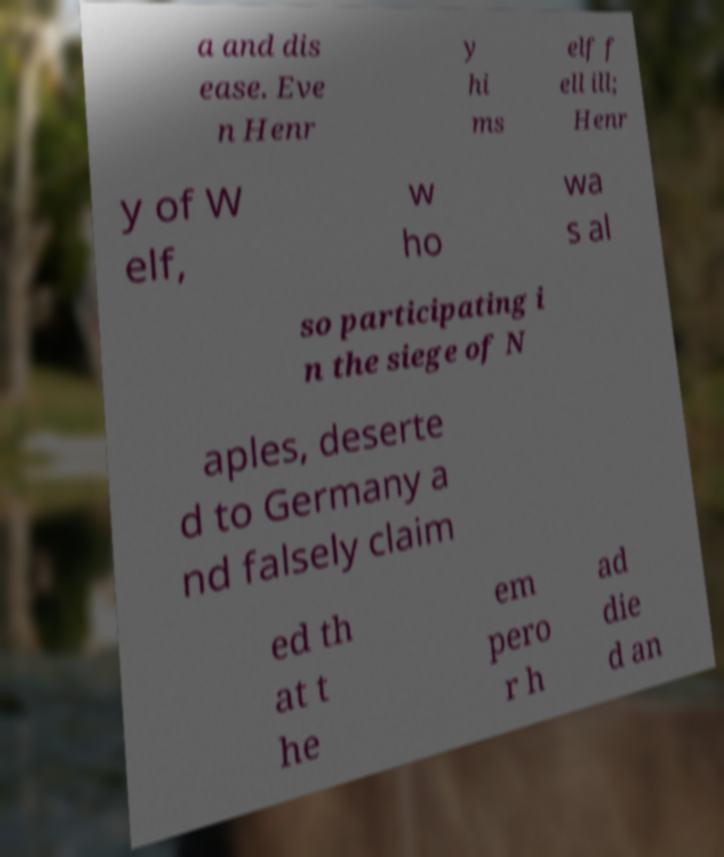For documentation purposes, I need the text within this image transcribed. Could you provide that? a and dis ease. Eve n Henr y hi ms elf f ell ill; Henr y of W elf, w ho wa s al so participating i n the siege of N aples, deserte d to Germany a nd falsely claim ed th at t he em pero r h ad die d an 